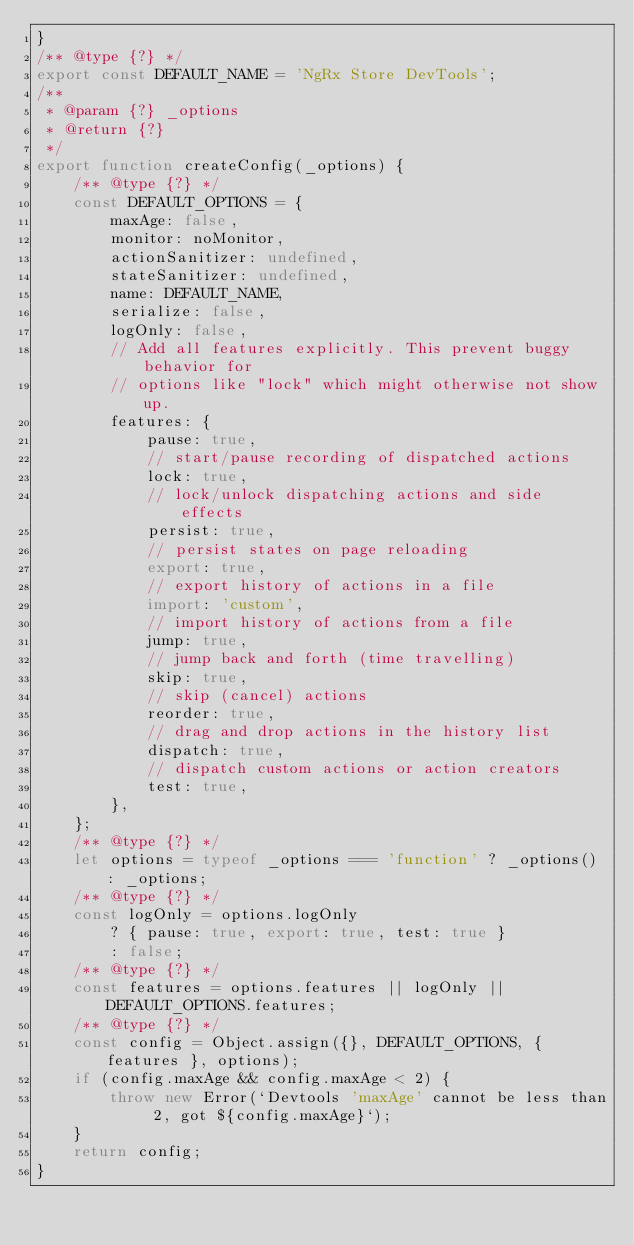Convert code to text. <code><loc_0><loc_0><loc_500><loc_500><_JavaScript_>}
/** @type {?} */
export const DEFAULT_NAME = 'NgRx Store DevTools';
/**
 * @param {?} _options
 * @return {?}
 */
export function createConfig(_options) {
    /** @type {?} */
    const DEFAULT_OPTIONS = {
        maxAge: false,
        monitor: noMonitor,
        actionSanitizer: undefined,
        stateSanitizer: undefined,
        name: DEFAULT_NAME,
        serialize: false,
        logOnly: false,
        // Add all features explicitly. This prevent buggy behavior for
        // options like "lock" which might otherwise not show up.
        features: {
            pause: true,
            // start/pause recording of dispatched actions
            lock: true,
            // lock/unlock dispatching actions and side effects
            persist: true,
            // persist states on page reloading
            export: true,
            // export history of actions in a file
            import: 'custom',
            // import history of actions from a file
            jump: true,
            // jump back and forth (time travelling)
            skip: true,
            // skip (cancel) actions
            reorder: true,
            // drag and drop actions in the history list
            dispatch: true,
            // dispatch custom actions or action creators
            test: true,
        },
    };
    /** @type {?} */
    let options = typeof _options === 'function' ? _options() : _options;
    /** @type {?} */
    const logOnly = options.logOnly
        ? { pause: true, export: true, test: true }
        : false;
    /** @type {?} */
    const features = options.features || logOnly || DEFAULT_OPTIONS.features;
    /** @type {?} */
    const config = Object.assign({}, DEFAULT_OPTIONS, { features }, options);
    if (config.maxAge && config.maxAge < 2) {
        throw new Error(`Devtools 'maxAge' cannot be less than 2, got ${config.maxAge}`);
    }
    return config;
}</code> 